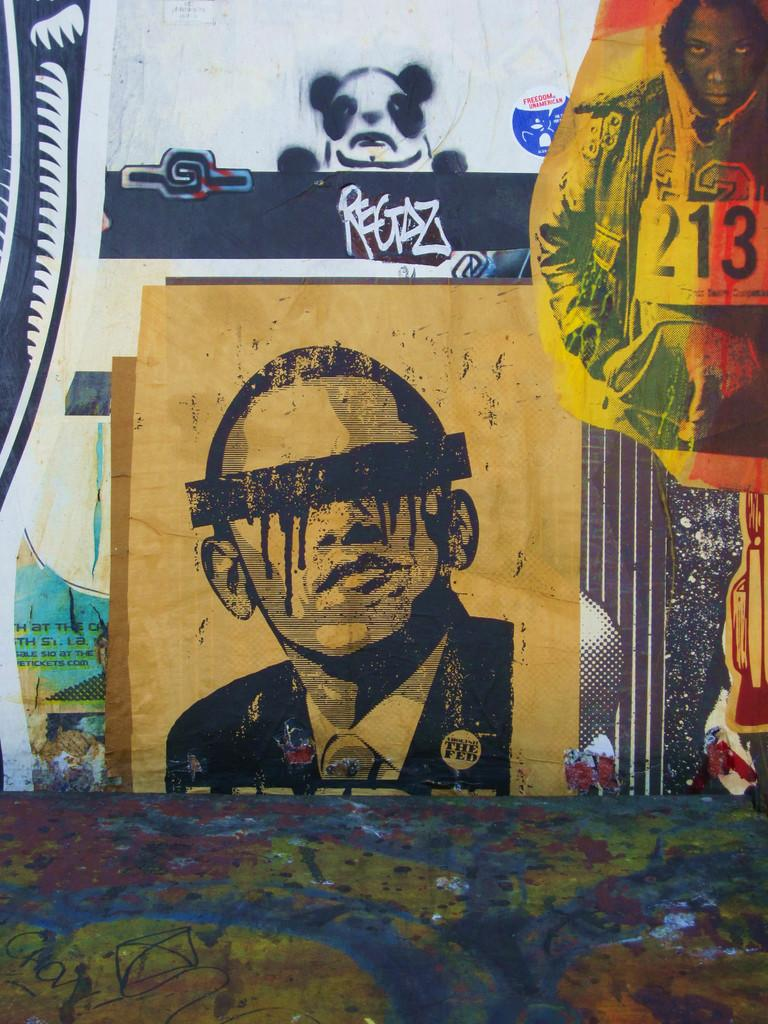<image>
Write a terse but informative summary of the picture. A drawing of Obama with a bar over his eyes wearing a button that says The Fed. 